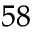<formula> <loc_0><loc_0><loc_500><loc_500>^ { 5 8 }</formula> 